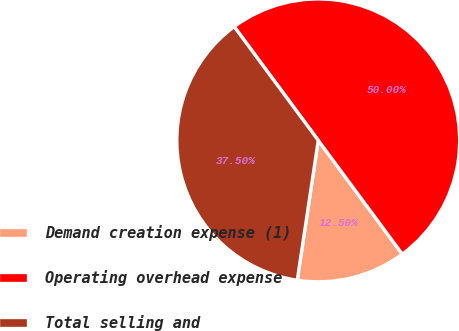Convert chart to OTSL. <chart><loc_0><loc_0><loc_500><loc_500><pie_chart><fcel>Demand creation expense (1)<fcel>Operating overhead expense<fcel>Total selling and<nl><fcel>12.5%<fcel>50.0%<fcel>37.5%<nl></chart> 